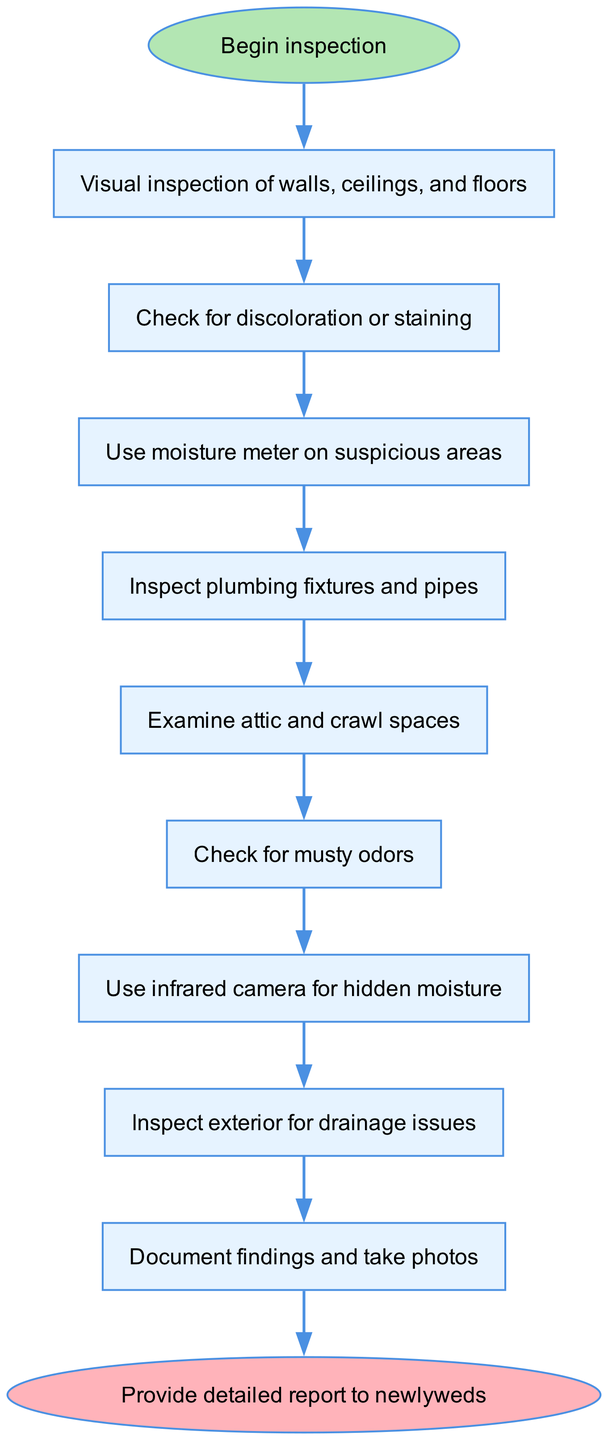What is the first step in the inspection process? The diagram starts with "Begin inspection" as the first step, leading directly to the first detailed action item.
Answer: Begin inspection How many total steps are in the inspection process? The diagram contains a total of nine detailed steps that follow the initial starting point and lead to a final end point.
Answer: 9 What is checked after inspecting plumbing fixtures and pipes? After inspecting plumbing fixtures and pipes, the next step is to examine the attic and crawl spaces, as indicated in the flow of the diagram.
Answer: Examine attic and crawl spaces Which step comes before using an infrared camera for hidden moisture? The step before using an infrared camera is checking for musty odors, reflecting a sequential inspection approach to detect possible water issues.
Answer: Check for musty odors What is documented as the last action in the inspection process? The last action before concluding the inspection process is to document findings and take photos, which indicates record-keeping is the final step.
Answer: Document findings and take photos What actions precede checking for discoloration or staining? The actions that precede checking for discoloration or staining include beginning the inspection and conducting a visual inspection of walls, ceilings, and floors.
Answer: Begin inspection, visual inspection of walls, ceilings, and floors What is the end result of completing the inspection process? The end result after completing all inspection steps is to provide a detailed report to the newlyweds, summarizing the findings from the inspection process.
Answer: Provide detailed report to newlyweds How many steps involve the use of specialized tools like moisture meters or infrared cameras? There are two steps involving the use of specialized tools: one for using a moisture meter on suspicious areas, and another for using an infrared camera for hidden moisture, both aimed at detecting water damage.
Answer: 2 What is the primary focus of the visual inspection step? The primary focus of the visual inspection step is to examine walls, ceilings, and floors for any visible signs of water damage.
Answer: Walls, ceilings, and floors 